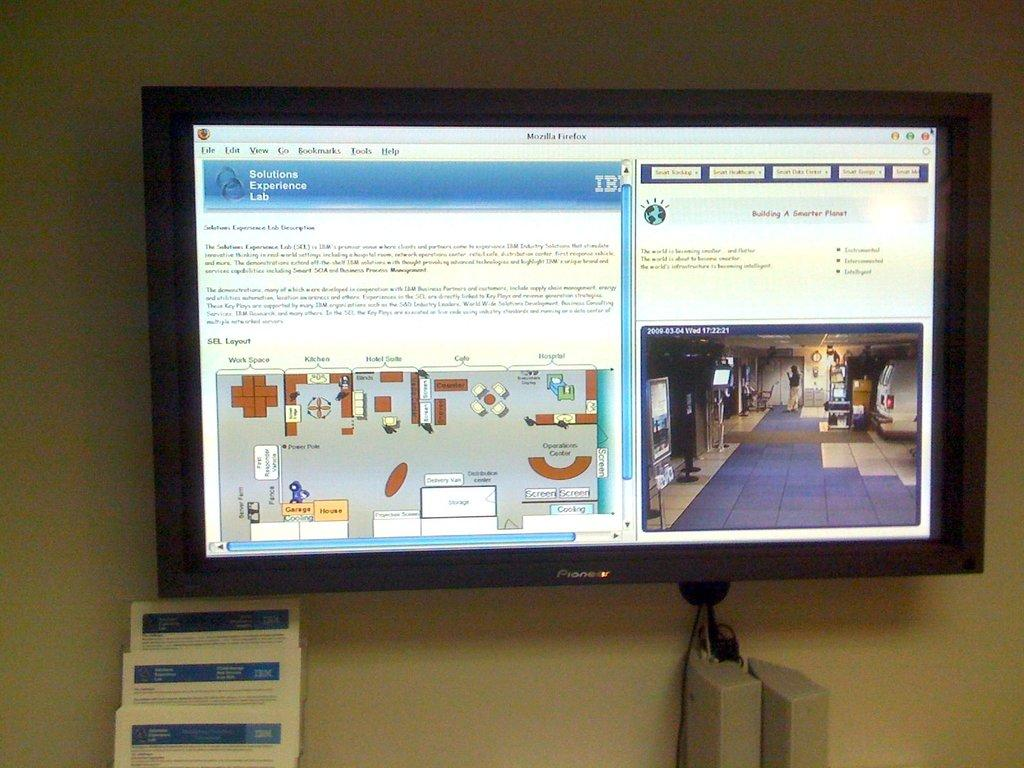<image>
Offer a succinct explanation of the picture presented. A screen showing a page from the Solutions Experience Lab hanging on a wall. 